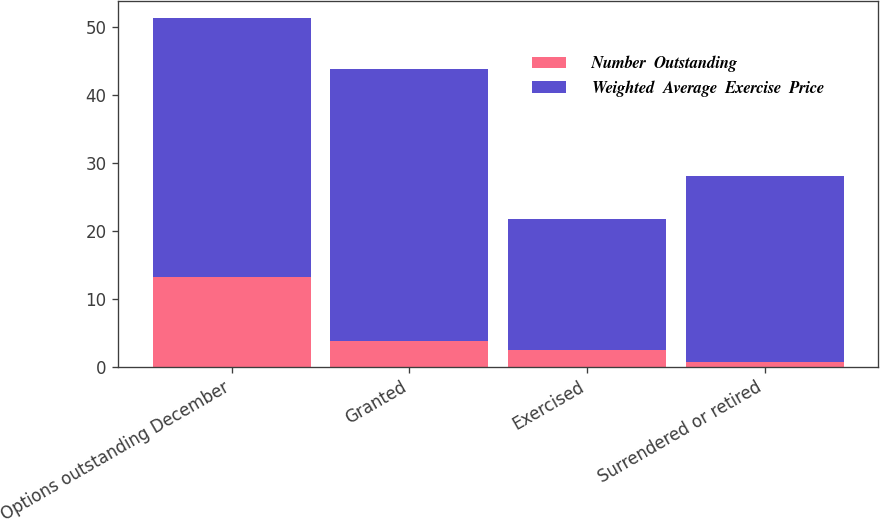Convert chart to OTSL. <chart><loc_0><loc_0><loc_500><loc_500><stacked_bar_chart><ecel><fcel>Options outstanding December<fcel>Granted<fcel>Exercised<fcel>Surrendered or retired<nl><fcel>Number  Outstanding<fcel>13.2<fcel>3.8<fcel>2.5<fcel>0.7<nl><fcel>Weighted  Average  Exercise  Price<fcel>38.15<fcel>40.01<fcel>19.31<fcel>27.43<nl></chart> 